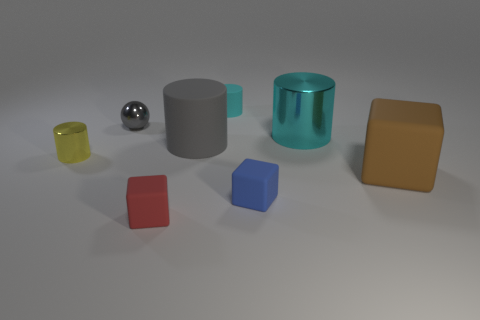Subtract 1 cylinders. How many cylinders are left? 3 Add 1 small cubes. How many objects exist? 9 Subtract all balls. How many objects are left? 7 Subtract all red objects. Subtract all tiny yellow cylinders. How many objects are left? 6 Add 6 large cyan objects. How many large cyan objects are left? 7 Add 4 red cylinders. How many red cylinders exist? 4 Subtract 0 purple balls. How many objects are left? 8 